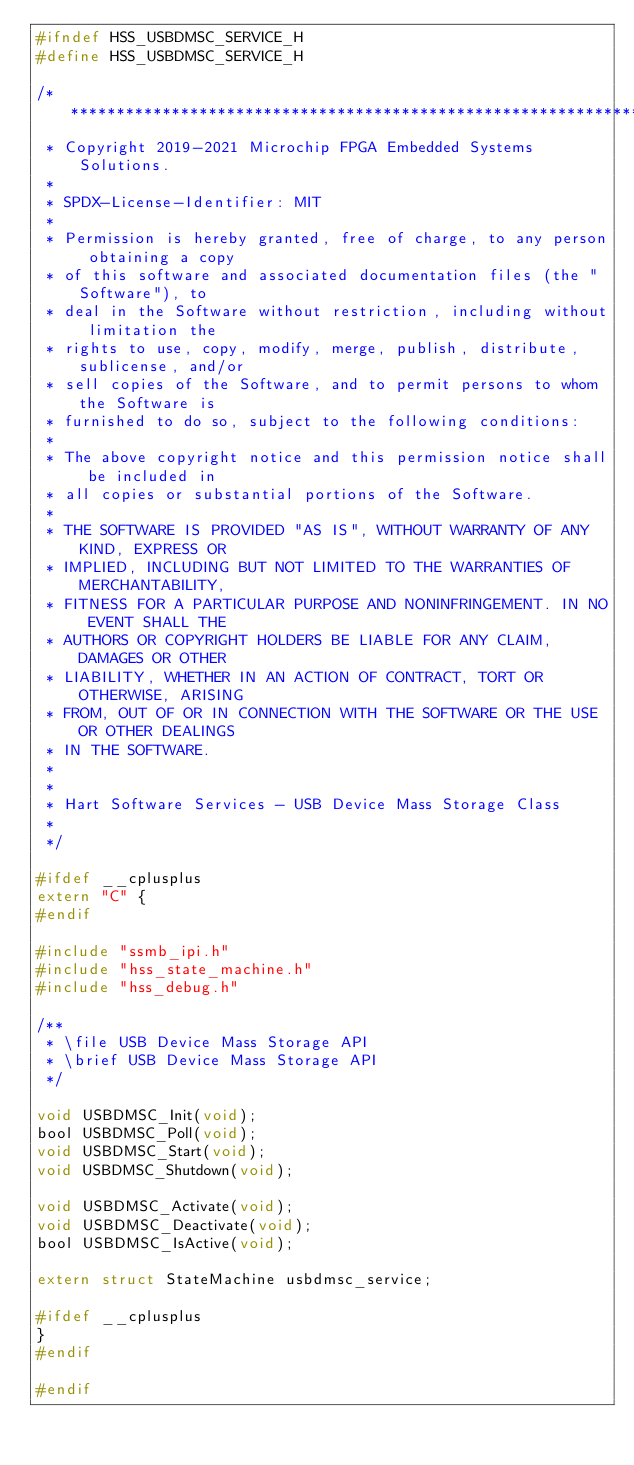<code> <loc_0><loc_0><loc_500><loc_500><_C_>#ifndef HSS_USBDMSC_SERVICE_H
#define HSS_USBDMSC_SERVICE_H

/*******************************************************************************
 * Copyright 2019-2021 Microchip FPGA Embedded Systems Solutions.
 *
 * SPDX-License-Identifier: MIT
 *
 * Permission is hereby granted, free of charge, to any person obtaining a copy
 * of this software and associated documentation files (the "Software"), to
 * deal in the Software without restriction, including without limitation the
 * rights to use, copy, modify, merge, publish, distribute, sublicense, and/or
 * sell copies of the Software, and to permit persons to whom the Software is
 * furnished to do so, subject to the following conditions:
 *
 * The above copyright notice and this permission notice shall be included in
 * all copies or substantial portions of the Software.
 *
 * THE SOFTWARE IS PROVIDED "AS IS", WITHOUT WARRANTY OF ANY KIND, EXPRESS OR
 * IMPLIED, INCLUDING BUT NOT LIMITED TO THE WARRANTIES OF MERCHANTABILITY,
 * FITNESS FOR A PARTICULAR PURPOSE AND NONINFRINGEMENT. IN NO EVENT SHALL THE
 * AUTHORS OR COPYRIGHT HOLDERS BE LIABLE FOR ANY CLAIM, DAMAGES OR OTHER
 * LIABILITY, WHETHER IN AN ACTION OF CONTRACT, TORT OR OTHERWISE, ARISING
 * FROM, OUT OF OR IN CONNECTION WITH THE SOFTWARE OR THE USE OR OTHER DEALINGS
 * IN THE SOFTWARE.
 *
 *
 * Hart Software Services - USB Device Mass Storage Class
 *
 */

#ifdef __cplusplus
extern "C" {
#endif

#include "ssmb_ipi.h"
#include "hss_state_machine.h"
#include "hss_debug.h"

/**
 * \file USB Device Mass Storage API
 * \brief USB Device Mass Storage API
 */

void USBDMSC_Init(void);
bool USBDMSC_Poll(void);
void USBDMSC_Start(void);
void USBDMSC_Shutdown(void);

void USBDMSC_Activate(void);
void USBDMSC_Deactivate(void);
bool USBDMSC_IsActive(void);

extern struct StateMachine usbdmsc_service;

#ifdef __cplusplus
}
#endif

#endif
</code> 